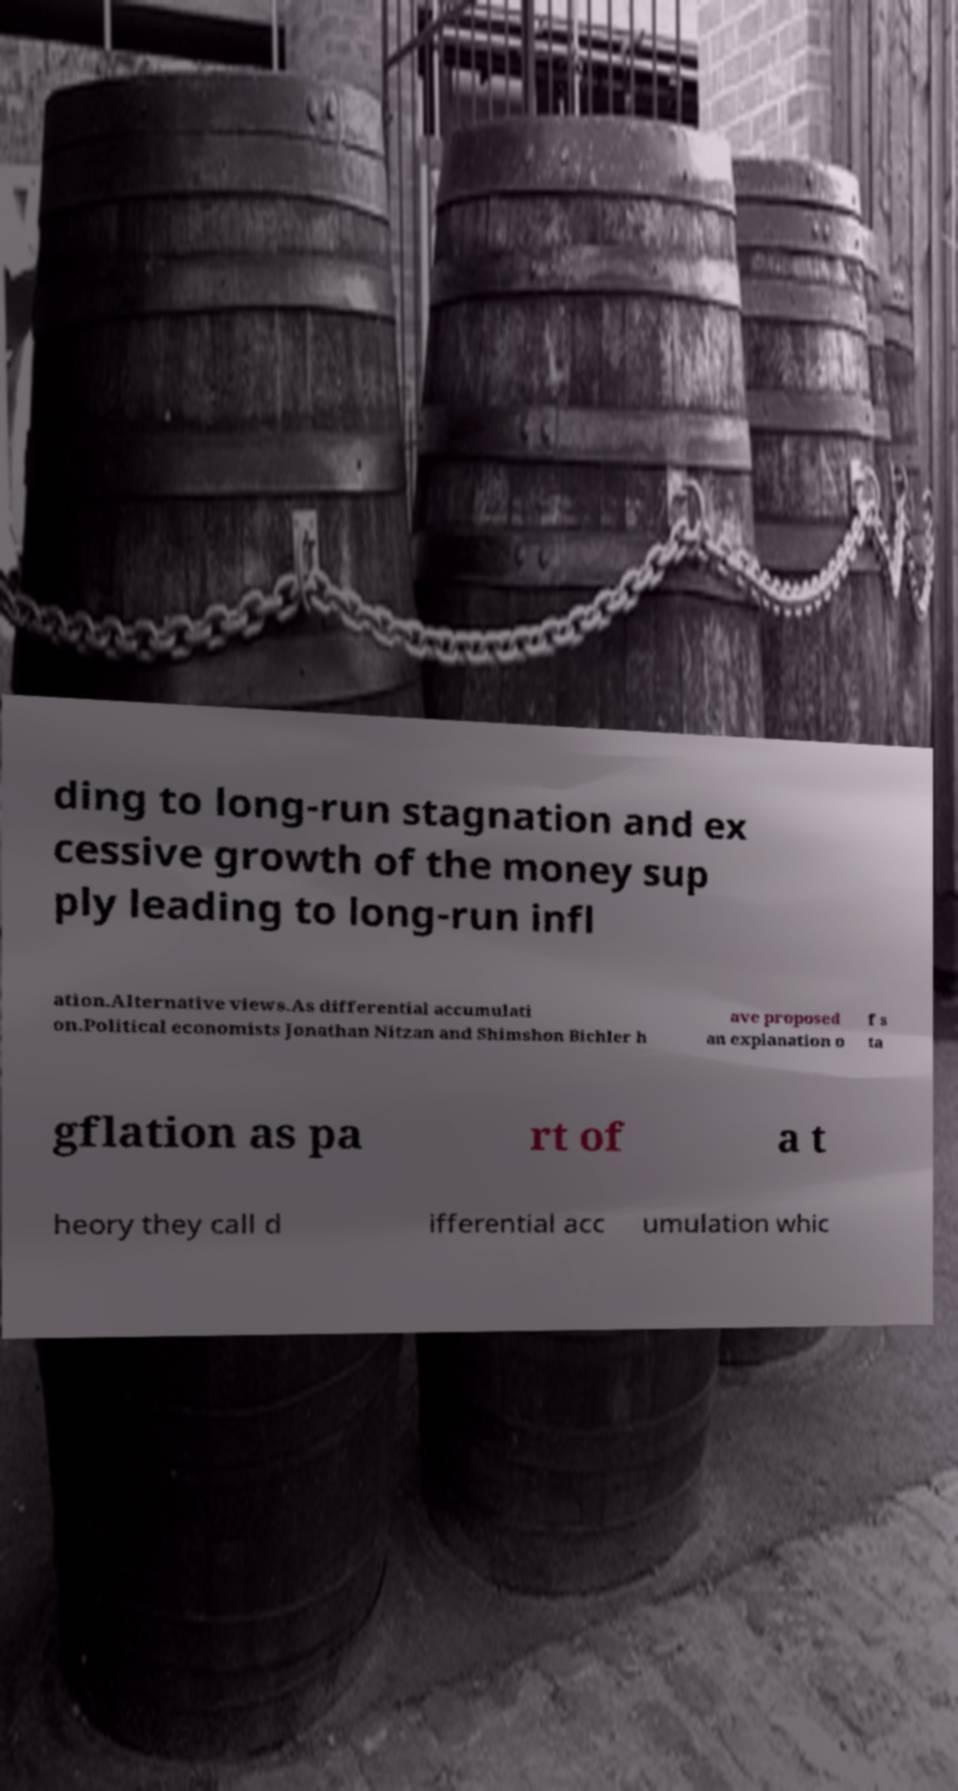What messages or text are displayed in this image? I need them in a readable, typed format. ding to long-run stagnation and ex cessive growth of the money sup ply leading to long-run infl ation.Alternative views.As differential accumulati on.Political economists Jonathan Nitzan and Shimshon Bichler h ave proposed an explanation o f s ta gflation as pa rt of a t heory they call d ifferential acc umulation whic 